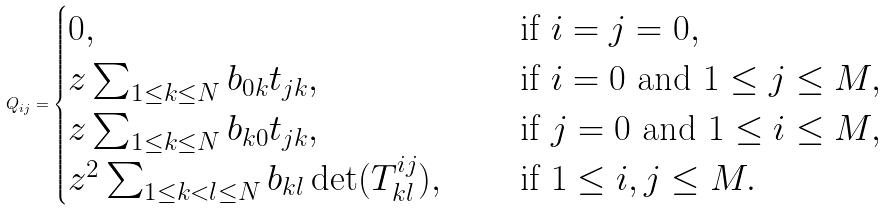Convert formula to latex. <formula><loc_0><loc_0><loc_500><loc_500>Q _ { i j } = \begin{cases} 0 , & \quad \text { if } i = j = 0 , \\ z \sum _ { 1 \leq k \leq N } b _ { 0 k } t _ { j k } , & \quad \text { if } i = 0 \text { and } 1 \leq j \leq M , \\ z \sum _ { 1 \leq k \leq N } b _ { k 0 } t _ { j k } , & \quad \text { if } j = 0 \text { and } 1 \leq i \leq M , \\ z ^ { 2 } \sum _ { 1 \leq k < l \leq N } b _ { k l } \det ( T ^ { i j } _ { k l } ) , & \quad \text { if } 1 \leq i , j \leq M . \end{cases}</formula> 